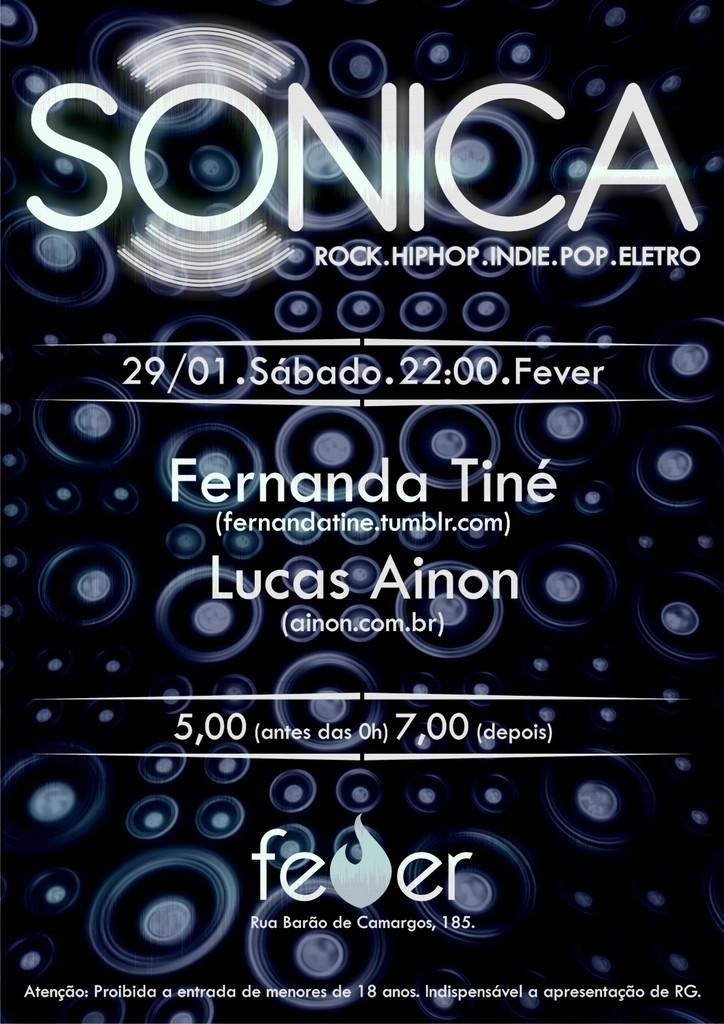What can be seen in the picture? There is a poster in the picture. What is featured on the poster? The poster contains text. What type of key is depicted on the poster? There is no key present on the poster; it only contains text. How is the lumber used in the image? There is no lumber present in the image; it only features a poster with text. 